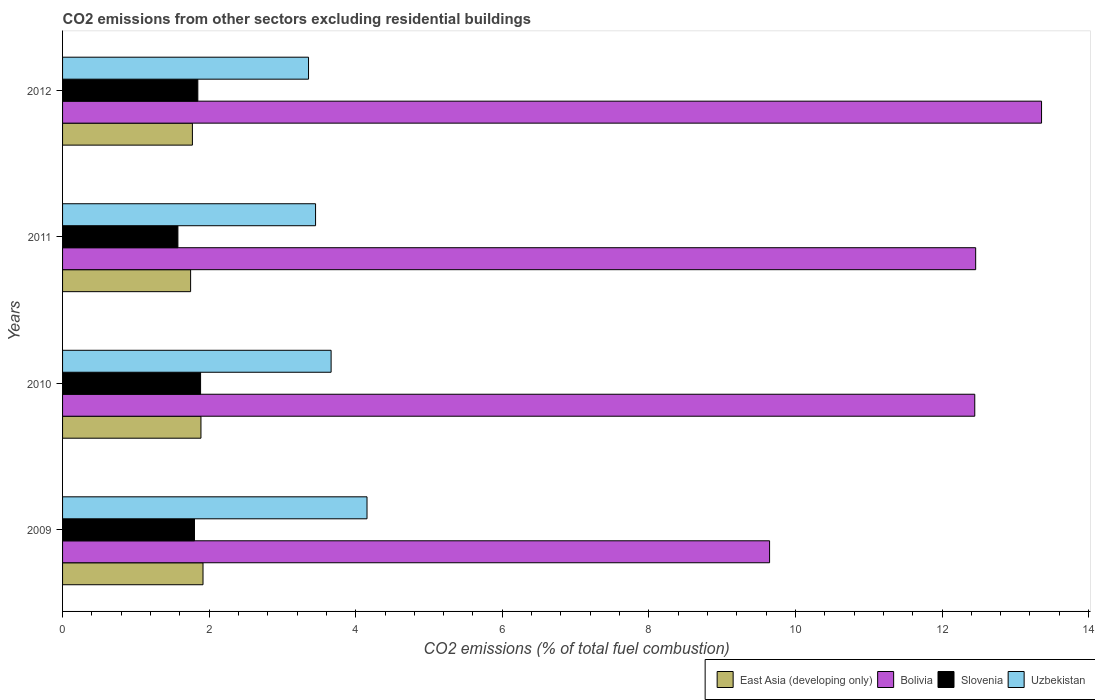How many different coloured bars are there?
Keep it short and to the point. 4. Are the number of bars on each tick of the Y-axis equal?
Provide a short and direct response. Yes. How many bars are there on the 4th tick from the bottom?
Provide a short and direct response. 4. What is the total CO2 emitted in Uzbekistan in 2009?
Make the answer very short. 4.15. Across all years, what is the maximum total CO2 emitted in Uzbekistan?
Provide a succinct answer. 4.15. Across all years, what is the minimum total CO2 emitted in Bolivia?
Give a very brief answer. 9.65. What is the total total CO2 emitted in Slovenia in the graph?
Your response must be concise. 7.1. What is the difference between the total CO2 emitted in Bolivia in 2010 and that in 2012?
Ensure brevity in your answer.  -0.91. What is the difference between the total CO2 emitted in Uzbekistan in 2009 and the total CO2 emitted in Bolivia in 2011?
Provide a succinct answer. -8.3. What is the average total CO2 emitted in Bolivia per year?
Offer a terse response. 11.98. In the year 2012, what is the difference between the total CO2 emitted in Bolivia and total CO2 emitted in Uzbekistan?
Provide a short and direct response. 10. In how many years, is the total CO2 emitted in Slovenia greater than 9.2 ?
Give a very brief answer. 0. What is the ratio of the total CO2 emitted in Slovenia in 2010 to that in 2011?
Offer a very short reply. 1.2. Is the difference between the total CO2 emitted in Bolivia in 2009 and 2012 greater than the difference between the total CO2 emitted in Uzbekistan in 2009 and 2012?
Your answer should be very brief. No. What is the difference between the highest and the second highest total CO2 emitted in Bolivia?
Offer a very short reply. 0.9. What is the difference between the highest and the lowest total CO2 emitted in Slovenia?
Your response must be concise. 0.31. In how many years, is the total CO2 emitted in Uzbekistan greater than the average total CO2 emitted in Uzbekistan taken over all years?
Make the answer very short. 2. Is the sum of the total CO2 emitted in Bolivia in 2009 and 2012 greater than the maximum total CO2 emitted in East Asia (developing only) across all years?
Offer a terse response. Yes. What does the 2nd bar from the top in 2009 represents?
Provide a short and direct response. Slovenia. What does the 2nd bar from the bottom in 2010 represents?
Your response must be concise. Bolivia. Is it the case that in every year, the sum of the total CO2 emitted in East Asia (developing only) and total CO2 emitted in Bolivia is greater than the total CO2 emitted in Slovenia?
Offer a terse response. Yes. How many years are there in the graph?
Your response must be concise. 4. What is the difference between two consecutive major ticks on the X-axis?
Give a very brief answer. 2. How many legend labels are there?
Give a very brief answer. 4. How are the legend labels stacked?
Make the answer very short. Horizontal. What is the title of the graph?
Keep it short and to the point. CO2 emissions from other sectors excluding residential buildings. What is the label or title of the X-axis?
Keep it short and to the point. CO2 emissions (% of total fuel combustion). What is the CO2 emissions (% of total fuel combustion) of East Asia (developing only) in 2009?
Provide a succinct answer. 1.92. What is the CO2 emissions (% of total fuel combustion) of Bolivia in 2009?
Provide a short and direct response. 9.65. What is the CO2 emissions (% of total fuel combustion) in Slovenia in 2009?
Keep it short and to the point. 1.8. What is the CO2 emissions (% of total fuel combustion) of Uzbekistan in 2009?
Make the answer very short. 4.15. What is the CO2 emissions (% of total fuel combustion) in East Asia (developing only) in 2010?
Provide a succinct answer. 1.89. What is the CO2 emissions (% of total fuel combustion) of Bolivia in 2010?
Make the answer very short. 12.45. What is the CO2 emissions (% of total fuel combustion) of Slovenia in 2010?
Keep it short and to the point. 1.88. What is the CO2 emissions (% of total fuel combustion) in Uzbekistan in 2010?
Keep it short and to the point. 3.66. What is the CO2 emissions (% of total fuel combustion) in East Asia (developing only) in 2011?
Offer a very short reply. 1.75. What is the CO2 emissions (% of total fuel combustion) of Bolivia in 2011?
Your answer should be very brief. 12.46. What is the CO2 emissions (% of total fuel combustion) of Slovenia in 2011?
Your answer should be compact. 1.57. What is the CO2 emissions (% of total fuel combustion) in Uzbekistan in 2011?
Ensure brevity in your answer.  3.45. What is the CO2 emissions (% of total fuel combustion) of East Asia (developing only) in 2012?
Your response must be concise. 1.77. What is the CO2 emissions (% of total fuel combustion) in Bolivia in 2012?
Your answer should be compact. 13.36. What is the CO2 emissions (% of total fuel combustion) in Slovenia in 2012?
Keep it short and to the point. 1.85. What is the CO2 emissions (% of total fuel combustion) in Uzbekistan in 2012?
Ensure brevity in your answer.  3.36. Across all years, what is the maximum CO2 emissions (% of total fuel combustion) in East Asia (developing only)?
Your response must be concise. 1.92. Across all years, what is the maximum CO2 emissions (% of total fuel combustion) in Bolivia?
Your response must be concise. 13.36. Across all years, what is the maximum CO2 emissions (% of total fuel combustion) of Slovenia?
Provide a succinct answer. 1.88. Across all years, what is the maximum CO2 emissions (% of total fuel combustion) of Uzbekistan?
Give a very brief answer. 4.15. Across all years, what is the minimum CO2 emissions (% of total fuel combustion) of East Asia (developing only)?
Your response must be concise. 1.75. Across all years, what is the minimum CO2 emissions (% of total fuel combustion) in Bolivia?
Offer a very short reply. 9.65. Across all years, what is the minimum CO2 emissions (% of total fuel combustion) in Slovenia?
Make the answer very short. 1.57. Across all years, what is the minimum CO2 emissions (% of total fuel combustion) of Uzbekistan?
Your response must be concise. 3.36. What is the total CO2 emissions (% of total fuel combustion) in East Asia (developing only) in the graph?
Keep it short and to the point. 7.32. What is the total CO2 emissions (% of total fuel combustion) of Bolivia in the graph?
Provide a short and direct response. 47.91. What is the total CO2 emissions (% of total fuel combustion) in Slovenia in the graph?
Your answer should be very brief. 7.1. What is the total CO2 emissions (% of total fuel combustion) of Uzbekistan in the graph?
Your answer should be compact. 14.63. What is the difference between the CO2 emissions (% of total fuel combustion) in East Asia (developing only) in 2009 and that in 2010?
Your response must be concise. 0.03. What is the difference between the CO2 emissions (% of total fuel combustion) of Bolivia in 2009 and that in 2010?
Give a very brief answer. -2.8. What is the difference between the CO2 emissions (% of total fuel combustion) of Slovenia in 2009 and that in 2010?
Your answer should be compact. -0.08. What is the difference between the CO2 emissions (% of total fuel combustion) in Uzbekistan in 2009 and that in 2010?
Give a very brief answer. 0.49. What is the difference between the CO2 emissions (% of total fuel combustion) of East Asia (developing only) in 2009 and that in 2011?
Provide a short and direct response. 0.17. What is the difference between the CO2 emissions (% of total fuel combustion) of Bolivia in 2009 and that in 2011?
Offer a very short reply. -2.81. What is the difference between the CO2 emissions (% of total fuel combustion) of Slovenia in 2009 and that in 2011?
Make the answer very short. 0.23. What is the difference between the CO2 emissions (% of total fuel combustion) in Uzbekistan in 2009 and that in 2011?
Make the answer very short. 0.7. What is the difference between the CO2 emissions (% of total fuel combustion) of East Asia (developing only) in 2009 and that in 2012?
Provide a short and direct response. 0.14. What is the difference between the CO2 emissions (% of total fuel combustion) in Bolivia in 2009 and that in 2012?
Your answer should be compact. -3.71. What is the difference between the CO2 emissions (% of total fuel combustion) of Slovenia in 2009 and that in 2012?
Your answer should be very brief. -0.05. What is the difference between the CO2 emissions (% of total fuel combustion) of Uzbekistan in 2009 and that in 2012?
Provide a short and direct response. 0.8. What is the difference between the CO2 emissions (% of total fuel combustion) of East Asia (developing only) in 2010 and that in 2011?
Your answer should be compact. 0.14. What is the difference between the CO2 emissions (% of total fuel combustion) in Bolivia in 2010 and that in 2011?
Your response must be concise. -0.01. What is the difference between the CO2 emissions (% of total fuel combustion) of Slovenia in 2010 and that in 2011?
Offer a very short reply. 0.31. What is the difference between the CO2 emissions (% of total fuel combustion) in Uzbekistan in 2010 and that in 2011?
Make the answer very short. 0.21. What is the difference between the CO2 emissions (% of total fuel combustion) in East Asia (developing only) in 2010 and that in 2012?
Keep it short and to the point. 0.12. What is the difference between the CO2 emissions (% of total fuel combustion) of Bolivia in 2010 and that in 2012?
Your response must be concise. -0.91. What is the difference between the CO2 emissions (% of total fuel combustion) in Slovenia in 2010 and that in 2012?
Your answer should be very brief. 0.04. What is the difference between the CO2 emissions (% of total fuel combustion) in Uzbekistan in 2010 and that in 2012?
Offer a terse response. 0.31. What is the difference between the CO2 emissions (% of total fuel combustion) in East Asia (developing only) in 2011 and that in 2012?
Give a very brief answer. -0.02. What is the difference between the CO2 emissions (% of total fuel combustion) in Bolivia in 2011 and that in 2012?
Your answer should be compact. -0.9. What is the difference between the CO2 emissions (% of total fuel combustion) of Slovenia in 2011 and that in 2012?
Offer a very short reply. -0.27. What is the difference between the CO2 emissions (% of total fuel combustion) in Uzbekistan in 2011 and that in 2012?
Give a very brief answer. 0.1. What is the difference between the CO2 emissions (% of total fuel combustion) of East Asia (developing only) in 2009 and the CO2 emissions (% of total fuel combustion) of Bolivia in 2010?
Keep it short and to the point. -10.53. What is the difference between the CO2 emissions (% of total fuel combustion) in East Asia (developing only) in 2009 and the CO2 emissions (% of total fuel combustion) in Slovenia in 2010?
Your answer should be compact. 0.03. What is the difference between the CO2 emissions (% of total fuel combustion) in East Asia (developing only) in 2009 and the CO2 emissions (% of total fuel combustion) in Uzbekistan in 2010?
Ensure brevity in your answer.  -1.75. What is the difference between the CO2 emissions (% of total fuel combustion) in Bolivia in 2009 and the CO2 emissions (% of total fuel combustion) in Slovenia in 2010?
Provide a succinct answer. 7.76. What is the difference between the CO2 emissions (% of total fuel combustion) in Bolivia in 2009 and the CO2 emissions (% of total fuel combustion) in Uzbekistan in 2010?
Offer a terse response. 5.98. What is the difference between the CO2 emissions (% of total fuel combustion) in Slovenia in 2009 and the CO2 emissions (% of total fuel combustion) in Uzbekistan in 2010?
Offer a terse response. -1.86. What is the difference between the CO2 emissions (% of total fuel combustion) of East Asia (developing only) in 2009 and the CO2 emissions (% of total fuel combustion) of Bolivia in 2011?
Your answer should be very brief. -10.54. What is the difference between the CO2 emissions (% of total fuel combustion) of East Asia (developing only) in 2009 and the CO2 emissions (% of total fuel combustion) of Slovenia in 2011?
Keep it short and to the point. 0.34. What is the difference between the CO2 emissions (% of total fuel combustion) of East Asia (developing only) in 2009 and the CO2 emissions (% of total fuel combustion) of Uzbekistan in 2011?
Provide a short and direct response. -1.54. What is the difference between the CO2 emissions (% of total fuel combustion) in Bolivia in 2009 and the CO2 emissions (% of total fuel combustion) in Slovenia in 2011?
Keep it short and to the point. 8.07. What is the difference between the CO2 emissions (% of total fuel combustion) in Bolivia in 2009 and the CO2 emissions (% of total fuel combustion) in Uzbekistan in 2011?
Your response must be concise. 6.2. What is the difference between the CO2 emissions (% of total fuel combustion) in Slovenia in 2009 and the CO2 emissions (% of total fuel combustion) in Uzbekistan in 2011?
Make the answer very short. -1.65. What is the difference between the CO2 emissions (% of total fuel combustion) in East Asia (developing only) in 2009 and the CO2 emissions (% of total fuel combustion) in Bolivia in 2012?
Make the answer very short. -11.44. What is the difference between the CO2 emissions (% of total fuel combustion) in East Asia (developing only) in 2009 and the CO2 emissions (% of total fuel combustion) in Slovenia in 2012?
Give a very brief answer. 0.07. What is the difference between the CO2 emissions (% of total fuel combustion) of East Asia (developing only) in 2009 and the CO2 emissions (% of total fuel combustion) of Uzbekistan in 2012?
Provide a succinct answer. -1.44. What is the difference between the CO2 emissions (% of total fuel combustion) of Bolivia in 2009 and the CO2 emissions (% of total fuel combustion) of Slovenia in 2012?
Your answer should be very brief. 7.8. What is the difference between the CO2 emissions (% of total fuel combustion) in Bolivia in 2009 and the CO2 emissions (% of total fuel combustion) in Uzbekistan in 2012?
Ensure brevity in your answer.  6.29. What is the difference between the CO2 emissions (% of total fuel combustion) of Slovenia in 2009 and the CO2 emissions (% of total fuel combustion) of Uzbekistan in 2012?
Give a very brief answer. -1.56. What is the difference between the CO2 emissions (% of total fuel combustion) of East Asia (developing only) in 2010 and the CO2 emissions (% of total fuel combustion) of Bolivia in 2011?
Provide a succinct answer. -10.57. What is the difference between the CO2 emissions (% of total fuel combustion) in East Asia (developing only) in 2010 and the CO2 emissions (% of total fuel combustion) in Slovenia in 2011?
Your response must be concise. 0.31. What is the difference between the CO2 emissions (% of total fuel combustion) in East Asia (developing only) in 2010 and the CO2 emissions (% of total fuel combustion) in Uzbekistan in 2011?
Your answer should be compact. -1.56. What is the difference between the CO2 emissions (% of total fuel combustion) in Bolivia in 2010 and the CO2 emissions (% of total fuel combustion) in Slovenia in 2011?
Your answer should be very brief. 10.87. What is the difference between the CO2 emissions (% of total fuel combustion) in Bolivia in 2010 and the CO2 emissions (% of total fuel combustion) in Uzbekistan in 2011?
Provide a succinct answer. 8.99. What is the difference between the CO2 emissions (% of total fuel combustion) in Slovenia in 2010 and the CO2 emissions (% of total fuel combustion) in Uzbekistan in 2011?
Your response must be concise. -1.57. What is the difference between the CO2 emissions (% of total fuel combustion) in East Asia (developing only) in 2010 and the CO2 emissions (% of total fuel combustion) in Bolivia in 2012?
Your response must be concise. -11.47. What is the difference between the CO2 emissions (% of total fuel combustion) in East Asia (developing only) in 2010 and the CO2 emissions (% of total fuel combustion) in Slovenia in 2012?
Give a very brief answer. 0.04. What is the difference between the CO2 emissions (% of total fuel combustion) of East Asia (developing only) in 2010 and the CO2 emissions (% of total fuel combustion) of Uzbekistan in 2012?
Keep it short and to the point. -1.47. What is the difference between the CO2 emissions (% of total fuel combustion) of Bolivia in 2010 and the CO2 emissions (% of total fuel combustion) of Slovenia in 2012?
Keep it short and to the point. 10.6. What is the difference between the CO2 emissions (% of total fuel combustion) in Bolivia in 2010 and the CO2 emissions (% of total fuel combustion) in Uzbekistan in 2012?
Provide a succinct answer. 9.09. What is the difference between the CO2 emissions (% of total fuel combustion) in Slovenia in 2010 and the CO2 emissions (% of total fuel combustion) in Uzbekistan in 2012?
Offer a very short reply. -1.47. What is the difference between the CO2 emissions (% of total fuel combustion) in East Asia (developing only) in 2011 and the CO2 emissions (% of total fuel combustion) in Bolivia in 2012?
Ensure brevity in your answer.  -11.61. What is the difference between the CO2 emissions (% of total fuel combustion) of East Asia (developing only) in 2011 and the CO2 emissions (% of total fuel combustion) of Slovenia in 2012?
Give a very brief answer. -0.1. What is the difference between the CO2 emissions (% of total fuel combustion) in East Asia (developing only) in 2011 and the CO2 emissions (% of total fuel combustion) in Uzbekistan in 2012?
Offer a terse response. -1.61. What is the difference between the CO2 emissions (% of total fuel combustion) in Bolivia in 2011 and the CO2 emissions (% of total fuel combustion) in Slovenia in 2012?
Provide a short and direct response. 10.61. What is the difference between the CO2 emissions (% of total fuel combustion) of Bolivia in 2011 and the CO2 emissions (% of total fuel combustion) of Uzbekistan in 2012?
Offer a very short reply. 9.1. What is the difference between the CO2 emissions (% of total fuel combustion) of Slovenia in 2011 and the CO2 emissions (% of total fuel combustion) of Uzbekistan in 2012?
Keep it short and to the point. -1.78. What is the average CO2 emissions (% of total fuel combustion) in East Asia (developing only) per year?
Your answer should be compact. 1.83. What is the average CO2 emissions (% of total fuel combustion) of Bolivia per year?
Provide a short and direct response. 11.98. What is the average CO2 emissions (% of total fuel combustion) in Slovenia per year?
Keep it short and to the point. 1.78. What is the average CO2 emissions (% of total fuel combustion) of Uzbekistan per year?
Ensure brevity in your answer.  3.66. In the year 2009, what is the difference between the CO2 emissions (% of total fuel combustion) of East Asia (developing only) and CO2 emissions (% of total fuel combustion) of Bolivia?
Your answer should be compact. -7.73. In the year 2009, what is the difference between the CO2 emissions (% of total fuel combustion) in East Asia (developing only) and CO2 emissions (% of total fuel combustion) in Slovenia?
Offer a very short reply. 0.12. In the year 2009, what is the difference between the CO2 emissions (% of total fuel combustion) in East Asia (developing only) and CO2 emissions (% of total fuel combustion) in Uzbekistan?
Give a very brief answer. -2.24. In the year 2009, what is the difference between the CO2 emissions (% of total fuel combustion) of Bolivia and CO2 emissions (% of total fuel combustion) of Slovenia?
Provide a short and direct response. 7.85. In the year 2009, what is the difference between the CO2 emissions (% of total fuel combustion) of Bolivia and CO2 emissions (% of total fuel combustion) of Uzbekistan?
Offer a very short reply. 5.49. In the year 2009, what is the difference between the CO2 emissions (% of total fuel combustion) in Slovenia and CO2 emissions (% of total fuel combustion) in Uzbekistan?
Provide a short and direct response. -2.35. In the year 2010, what is the difference between the CO2 emissions (% of total fuel combustion) of East Asia (developing only) and CO2 emissions (% of total fuel combustion) of Bolivia?
Your answer should be very brief. -10.56. In the year 2010, what is the difference between the CO2 emissions (% of total fuel combustion) of East Asia (developing only) and CO2 emissions (% of total fuel combustion) of Slovenia?
Your answer should be very brief. 0.01. In the year 2010, what is the difference between the CO2 emissions (% of total fuel combustion) of East Asia (developing only) and CO2 emissions (% of total fuel combustion) of Uzbekistan?
Offer a very short reply. -1.78. In the year 2010, what is the difference between the CO2 emissions (% of total fuel combustion) of Bolivia and CO2 emissions (% of total fuel combustion) of Slovenia?
Offer a very short reply. 10.56. In the year 2010, what is the difference between the CO2 emissions (% of total fuel combustion) in Bolivia and CO2 emissions (% of total fuel combustion) in Uzbekistan?
Provide a succinct answer. 8.78. In the year 2010, what is the difference between the CO2 emissions (% of total fuel combustion) of Slovenia and CO2 emissions (% of total fuel combustion) of Uzbekistan?
Provide a short and direct response. -1.78. In the year 2011, what is the difference between the CO2 emissions (% of total fuel combustion) of East Asia (developing only) and CO2 emissions (% of total fuel combustion) of Bolivia?
Your answer should be compact. -10.71. In the year 2011, what is the difference between the CO2 emissions (% of total fuel combustion) in East Asia (developing only) and CO2 emissions (% of total fuel combustion) in Slovenia?
Your response must be concise. 0.17. In the year 2011, what is the difference between the CO2 emissions (% of total fuel combustion) in East Asia (developing only) and CO2 emissions (% of total fuel combustion) in Uzbekistan?
Provide a succinct answer. -1.71. In the year 2011, what is the difference between the CO2 emissions (% of total fuel combustion) of Bolivia and CO2 emissions (% of total fuel combustion) of Slovenia?
Provide a succinct answer. 10.89. In the year 2011, what is the difference between the CO2 emissions (% of total fuel combustion) in Bolivia and CO2 emissions (% of total fuel combustion) in Uzbekistan?
Provide a succinct answer. 9.01. In the year 2011, what is the difference between the CO2 emissions (% of total fuel combustion) in Slovenia and CO2 emissions (% of total fuel combustion) in Uzbekistan?
Offer a very short reply. -1.88. In the year 2012, what is the difference between the CO2 emissions (% of total fuel combustion) in East Asia (developing only) and CO2 emissions (% of total fuel combustion) in Bolivia?
Offer a very short reply. -11.59. In the year 2012, what is the difference between the CO2 emissions (% of total fuel combustion) of East Asia (developing only) and CO2 emissions (% of total fuel combustion) of Slovenia?
Offer a terse response. -0.07. In the year 2012, what is the difference between the CO2 emissions (% of total fuel combustion) of East Asia (developing only) and CO2 emissions (% of total fuel combustion) of Uzbekistan?
Provide a short and direct response. -1.58. In the year 2012, what is the difference between the CO2 emissions (% of total fuel combustion) in Bolivia and CO2 emissions (% of total fuel combustion) in Slovenia?
Your answer should be very brief. 11.51. In the year 2012, what is the difference between the CO2 emissions (% of total fuel combustion) of Bolivia and CO2 emissions (% of total fuel combustion) of Uzbekistan?
Offer a very short reply. 10. In the year 2012, what is the difference between the CO2 emissions (% of total fuel combustion) in Slovenia and CO2 emissions (% of total fuel combustion) in Uzbekistan?
Keep it short and to the point. -1.51. What is the ratio of the CO2 emissions (% of total fuel combustion) of East Asia (developing only) in 2009 to that in 2010?
Offer a very short reply. 1.01. What is the ratio of the CO2 emissions (% of total fuel combustion) of Bolivia in 2009 to that in 2010?
Provide a short and direct response. 0.78. What is the ratio of the CO2 emissions (% of total fuel combustion) in Slovenia in 2009 to that in 2010?
Keep it short and to the point. 0.96. What is the ratio of the CO2 emissions (% of total fuel combustion) of Uzbekistan in 2009 to that in 2010?
Keep it short and to the point. 1.13. What is the ratio of the CO2 emissions (% of total fuel combustion) in East Asia (developing only) in 2009 to that in 2011?
Make the answer very short. 1.1. What is the ratio of the CO2 emissions (% of total fuel combustion) in Bolivia in 2009 to that in 2011?
Offer a very short reply. 0.77. What is the ratio of the CO2 emissions (% of total fuel combustion) in Slovenia in 2009 to that in 2011?
Keep it short and to the point. 1.14. What is the ratio of the CO2 emissions (% of total fuel combustion) in Uzbekistan in 2009 to that in 2011?
Your answer should be compact. 1.2. What is the ratio of the CO2 emissions (% of total fuel combustion) of East Asia (developing only) in 2009 to that in 2012?
Provide a short and direct response. 1.08. What is the ratio of the CO2 emissions (% of total fuel combustion) in Bolivia in 2009 to that in 2012?
Provide a short and direct response. 0.72. What is the ratio of the CO2 emissions (% of total fuel combustion) in Slovenia in 2009 to that in 2012?
Give a very brief answer. 0.98. What is the ratio of the CO2 emissions (% of total fuel combustion) in Uzbekistan in 2009 to that in 2012?
Your answer should be compact. 1.24. What is the ratio of the CO2 emissions (% of total fuel combustion) in East Asia (developing only) in 2010 to that in 2011?
Keep it short and to the point. 1.08. What is the ratio of the CO2 emissions (% of total fuel combustion) of Bolivia in 2010 to that in 2011?
Your response must be concise. 1. What is the ratio of the CO2 emissions (% of total fuel combustion) in Slovenia in 2010 to that in 2011?
Offer a very short reply. 1.2. What is the ratio of the CO2 emissions (% of total fuel combustion) in Uzbekistan in 2010 to that in 2011?
Keep it short and to the point. 1.06. What is the ratio of the CO2 emissions (% of total fuel combustion) of East Asia (developing only) in 2010 to that in 2012?
Your answer should be very brief. 1.07. What is the ratio of the CO2 emissions (% of total fuel combustion) of Bolivia in 2010 to that in 2012?
Keep it short and to the point. 0.93. What is the ratio of the CO2 emissions (% of total fuel combustion) of Slovenia in 2010 to that in 2012?
Make the answer very short. 1.02. What is the ratio of the CO2 emissions (% of total fuel combustion) in Uzbekistan in 2010 to that in 2012?
Offer a terse response. 1.09. What is the ratio of the CO2 emissions (% of total fuel combustion) of East Asia (developing only) in 2011 to that in 2012?
Offer a very short reply. 0.99. What is the ratio of the CO2 emissions (% of total fuel combustion) of Bolivia in 2011 to that in 2012?
Provide a short and direct response. 0.93. What is the ratio of the CO2 emissions (% of total fuel combustion) in Slovenia in 2011 to that in 2012?
Offer a very short reply. 0.85. What is the ratio of the CO2 emissions (% of total fuel combustion) of Uzbekistan in 2011 to that in 2012?
Offer a terse response. 1.03. What is the difference between the highest and the second highest CO2 emissions (% of total fuel combustion) in East Asia (developing only)?
Your answer should be very brief. 0.03. What is the difference between the highest and the second highest CO2 emissions (% of total fuel combustion) of Bolivia?
Make the answer very short. 0.9. What is the difference between the highest and the second highest CO2 emissions (% of total fuel combustion) of Slovenia?
Provide a short and direct response. 0.04. What is the difference between the highest and the second highest CO2 emissions (% of total fuel combustion) of Uzbekistan?
Offer a terse response. 0.49. What is the difference between the highest and the lowest CO2 emissions (% of total fuel combustion) in East Asia (developing only)?
Keep it short and to the point. 0.17. What is the difference between the highest and the lowest CO2 emissions (% of total fuel combustion) in Bolivia?
Offer a very short reply. 3.71. What is the difference between the highest and the lowest CO2 emissions (% of total fuel combustion) in Slovenia?
Provide a succinct answer. 0.31. What is the difference between the highest and the lowest CO2 emissions (% of total fuel combustion) of Uzbekistan?
Your response must be concise. 0.8. 